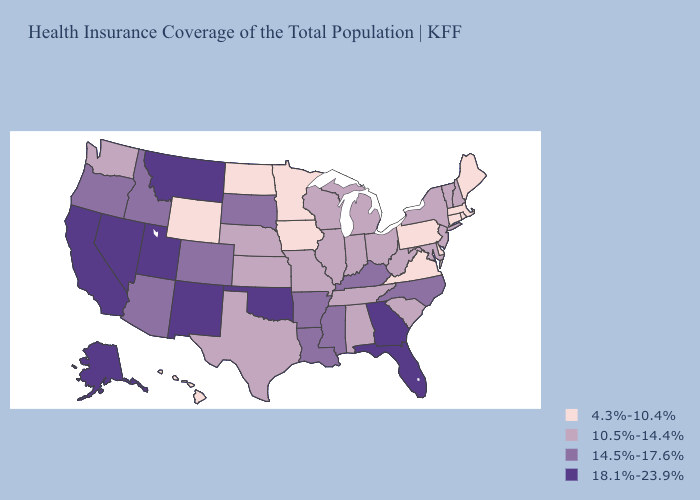Does Illinois have the highest value in the USA?
Give a very brief answer. No. What is the highest value in the USA?
Be succinct. 18.1%-23.9%. Among the states that border Minnesota , which have the lowest value?
Write a very short answer. Iowa, North Dakota. What is the highest value in the MidWest ?
Keep it brief. 14.5%-17.6%. Name the states that have a value in the range 14.5%-17.6%?
Give a very brief answer. Arizona, Arkansas, Colorado, Idaho, Kentucky, Louisiana, Mississippi, North Carolina, Oregon, South Dakota. What is the lowest value in the South?
Short answer required. 4.3%-10.4%. Name the states that have a value in the range 14.5%-17.6%?
Short answer required. Arizona, Arkansas, Colorado, Idaho, Kentucky, Louisiana, Mississippi, North Carolina, Oregon, South Dakota. Name the states that have a value in the range 4.3%-10.4%?
Concise answer only. Connecticut, Delaware, Hawaii, Iowa, Maine, Massachusetts, Minnesota, North Dakota, Pennsylvania, Rhode Island, Virginia, Wyoming. Name the states that have a value in the range 10.5%-14.4%?
Concise answer only. Alabama, Illinois, Indiana, Kansas, Maryland, Michigan, Missouri, Nebraska, New Hampshire, New Jersey, New York, Ohio, South Carolina, Tennessee, Texas, Vermont, Washington, West Virginia, Wisconsin. What is the value of Nebraska?
Answer briefly. 10.5%-14.4%. Among the states that border Iowa , which have the highest value?
Keep it brief. South Dakota. Which states have the highest value in the USA?
Give a very brief answer. Alaska, California, Florida, Georgia, Montana, Nevada, New Mexico, Oklahoma, Utah. Does the first symbol in the legend represent the smallest category?
Be succinct. Yes. What is the lowest value in states that border New Hampshire?
Answer briefly. 4.3%-10.4%. What is the value of Washington?
Be succinct. 10.5%-14.4%. 